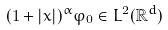Convert formula to latex. <formula><loc_0><loc_0><loc_500><loc_500>( 1 + | x | ) ^ { \alpha } \varphi _ { 0 } \in L ^ { 2 } ( \mathbb { R } ^ { d } )</formula> 